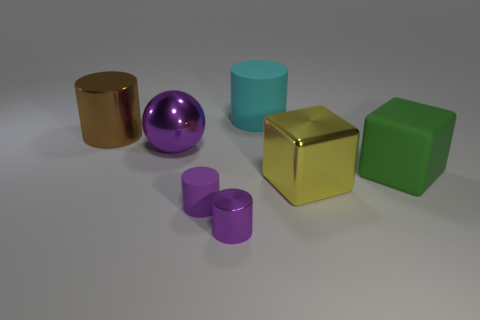Add 1 big brown objects. How many objects exist? 8 Subtract all balls. How many objects are left? 6 Add 5 big brown cylinders. How many big brown cylinders exist? 6 Subtract 0 red balls. How many objects are left? 7 Subtract all cyan metal blocks. Subtract all big matte cylinders. How many objects are left? 6 Add 2 large purple metallic objects. How many large purple metallic objects are left? 3 